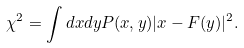<formula> <loc_0><loc_0><loc_500><loc_500>\chi ^ { 2 } = \int d x d y P ( x , y ) | x - F ( y ) | ^ { 2 } .</formula> 